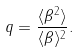<formula> <loc_0><loc_0><loc_500><loc_500>q = \frac { \langle \beta ^ { 2 } \rangle } { \langle \beta \rangle ^ { 2 } } .</formula> 